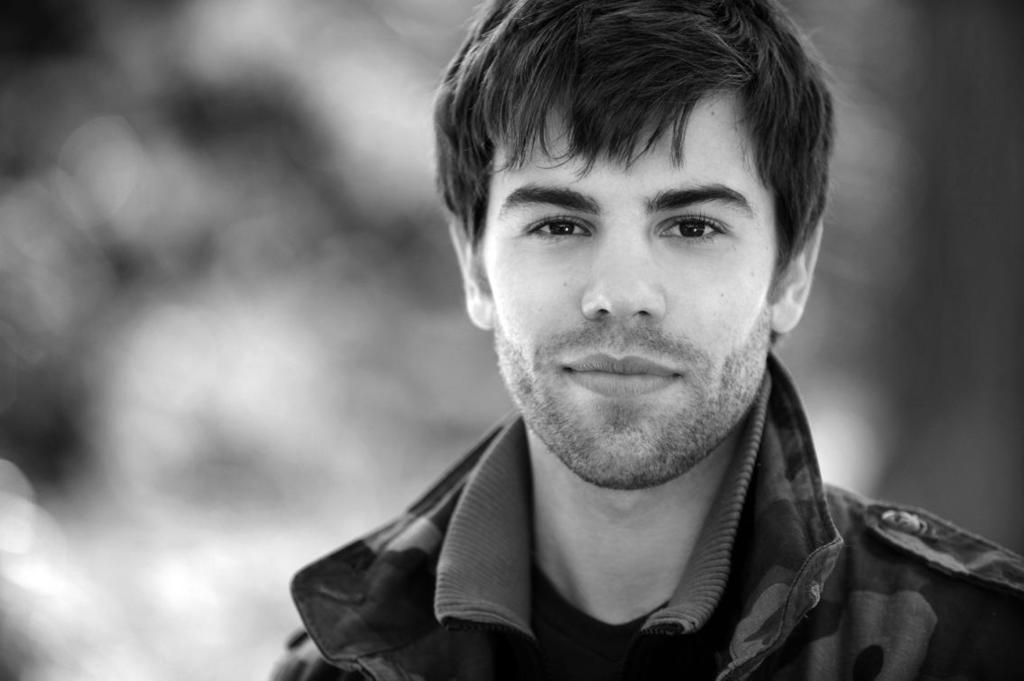In one or two sentences, can you explain what this image depicts? This is a black and white image. In this image we can see a person. In the background it is blur. 